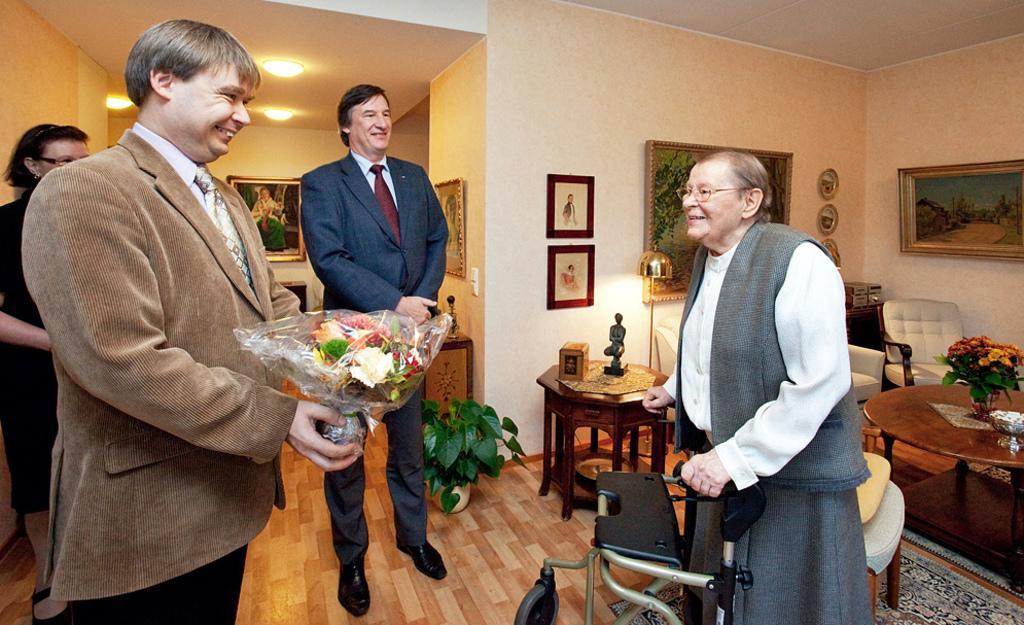In one or two sentences, can you explain what this image depicts? In this image we can see persons standing on the floor. In the background we can see electric lights, wall hangings attached to the walls, decors on the side tables and carpet on the floor. 